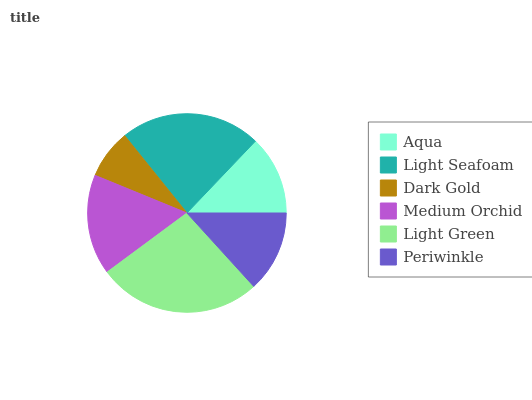Is Dark Gold the minimum?
Answer yes or no. Yes. Is Light Green the maximum?
Answer yes or no. Yes. Is Light Seafoam the minimum?
Answer yes or no. No. Is Light Seafoam the maximum?
Answer yes or no. No. Is Light Seafoam greater than Aqua?
Answer yes or no. Yes. Is Aqua less than Light Seafoam?
Answer yes or no. Yes. Is Aqua greater than Light Seafoam?
Answer yes or no. No. Is Light Seafoam less than Aqua?
Answer yes or no. No. Is Medium Orchid the high median?
Answer yes or no. Yes. Is Periwinkle the low median?
Answer yes or no. Yes. Is Light Seafoam the high median?
Answer yes or no. No. Is Dark Gold the low median?
Answer yes or no. No. 